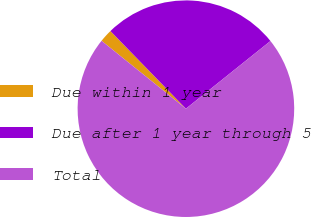<chart> <loc_0><loc_0><loc_500><loc_500><pie_chart><fcel>Due within 1 year<fcel>Due after 1 year through 5<fcel>Total<nl><fcel>1.94%<fcel>26.53%<fcel>71.53%<nl></chart> 